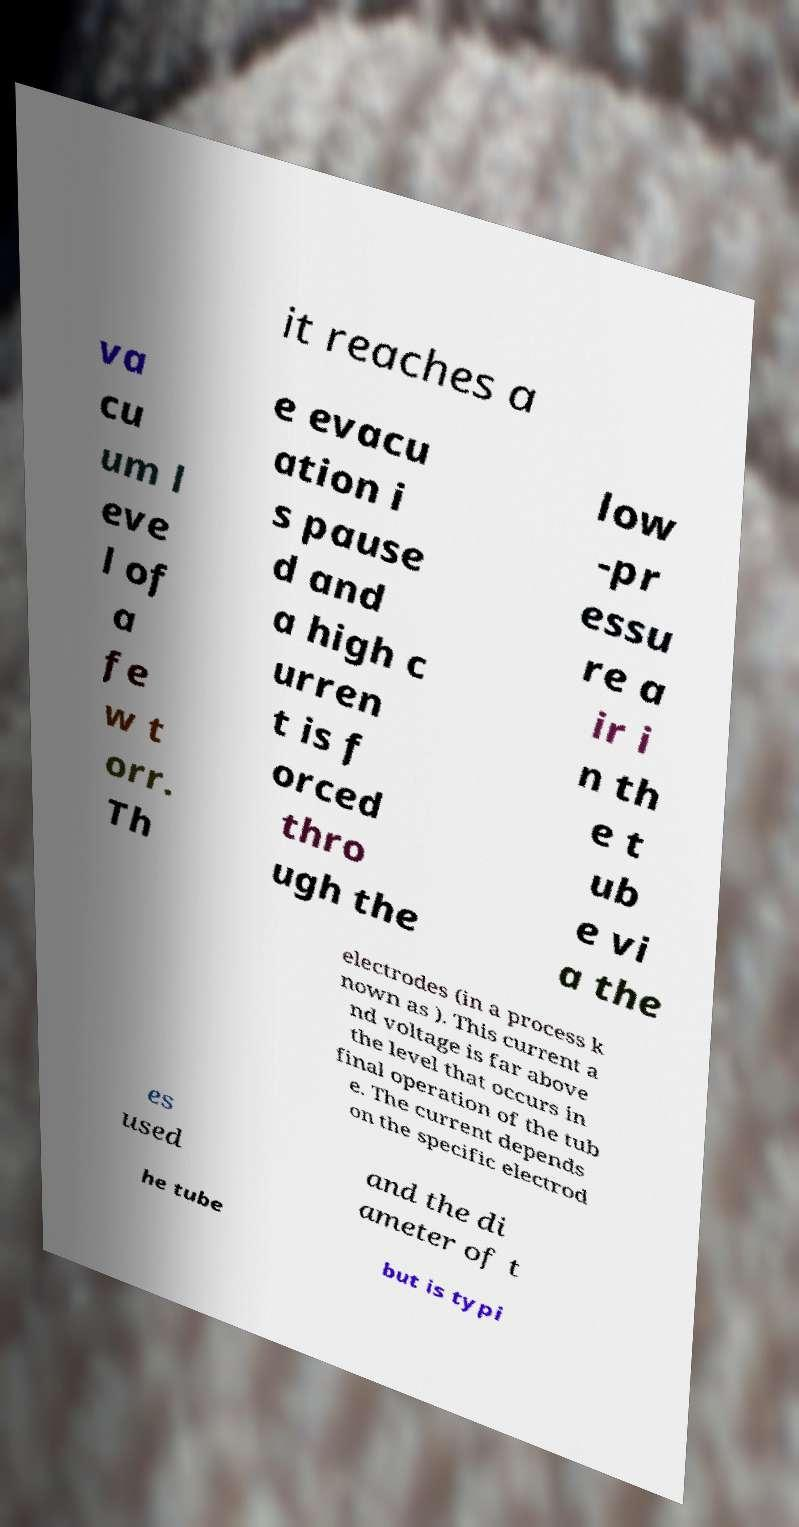Can you accurately transcribe the text from the provided image for me? it reaches a va cu um l eve l of a fe w t orr. Th e evacu ation i s pause d and a high c urren t is f orced thro ugh the low -pr essu re a ir i n th e t ub e vi a the electrodes (in a process k nown as ). This current a nd voltage is far above the level that occurs in final operation of the tub e. The current depends on the specific electrod es used and the di ameter of t he tube but is typi 